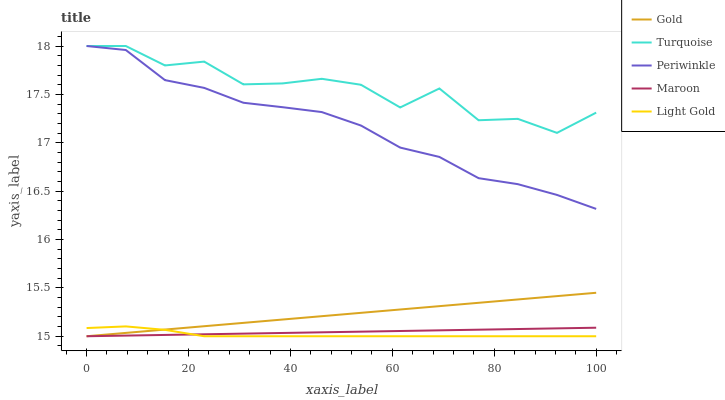Does Light Gold have the minimum area under the curve?
Answer yes or no. Yes. Does Turquoise have the maximum area under the curve?
Answer yes or no. Yes. Does Periwinkle have the minimum area under the curve?
Answer yes or no. No. Does Periwinkle have the maximum area under the curve?
Answer yes or no. No. Is Maroon the smoothest?
Answer yes or no. Yes. Is Turquoise the roughest?
Answer yes or no. Yes. Is Periwinkle the smoothest?
Answer yes or no. No. Is Periwinkle the roughest?
Answer yes or no. No. Does Light Gold have the lowest value?
Answer yes or no. Yes. Does Periwinkle have the lowest value?
Answer yes or no. No. Does Periwinkle have the highest value?
Answer yes or no. Yes. Does Maroon have the highest value?
Answer yes or no. No. Is Maroon less than Turquoise?
Answer yes or no. Yes. Is Turquoise greater than Light Gold?
Answer yes or no. Yes. Does Maroon intersect Gold?
Answer yes or no. Yes. Is Maroon less than Gold?
Answer yes or no. No. Is Maroon greater than Gold?
Answer yes or no. No. Does Maroon intersect Turquoise?
Answer yes or no. No. 